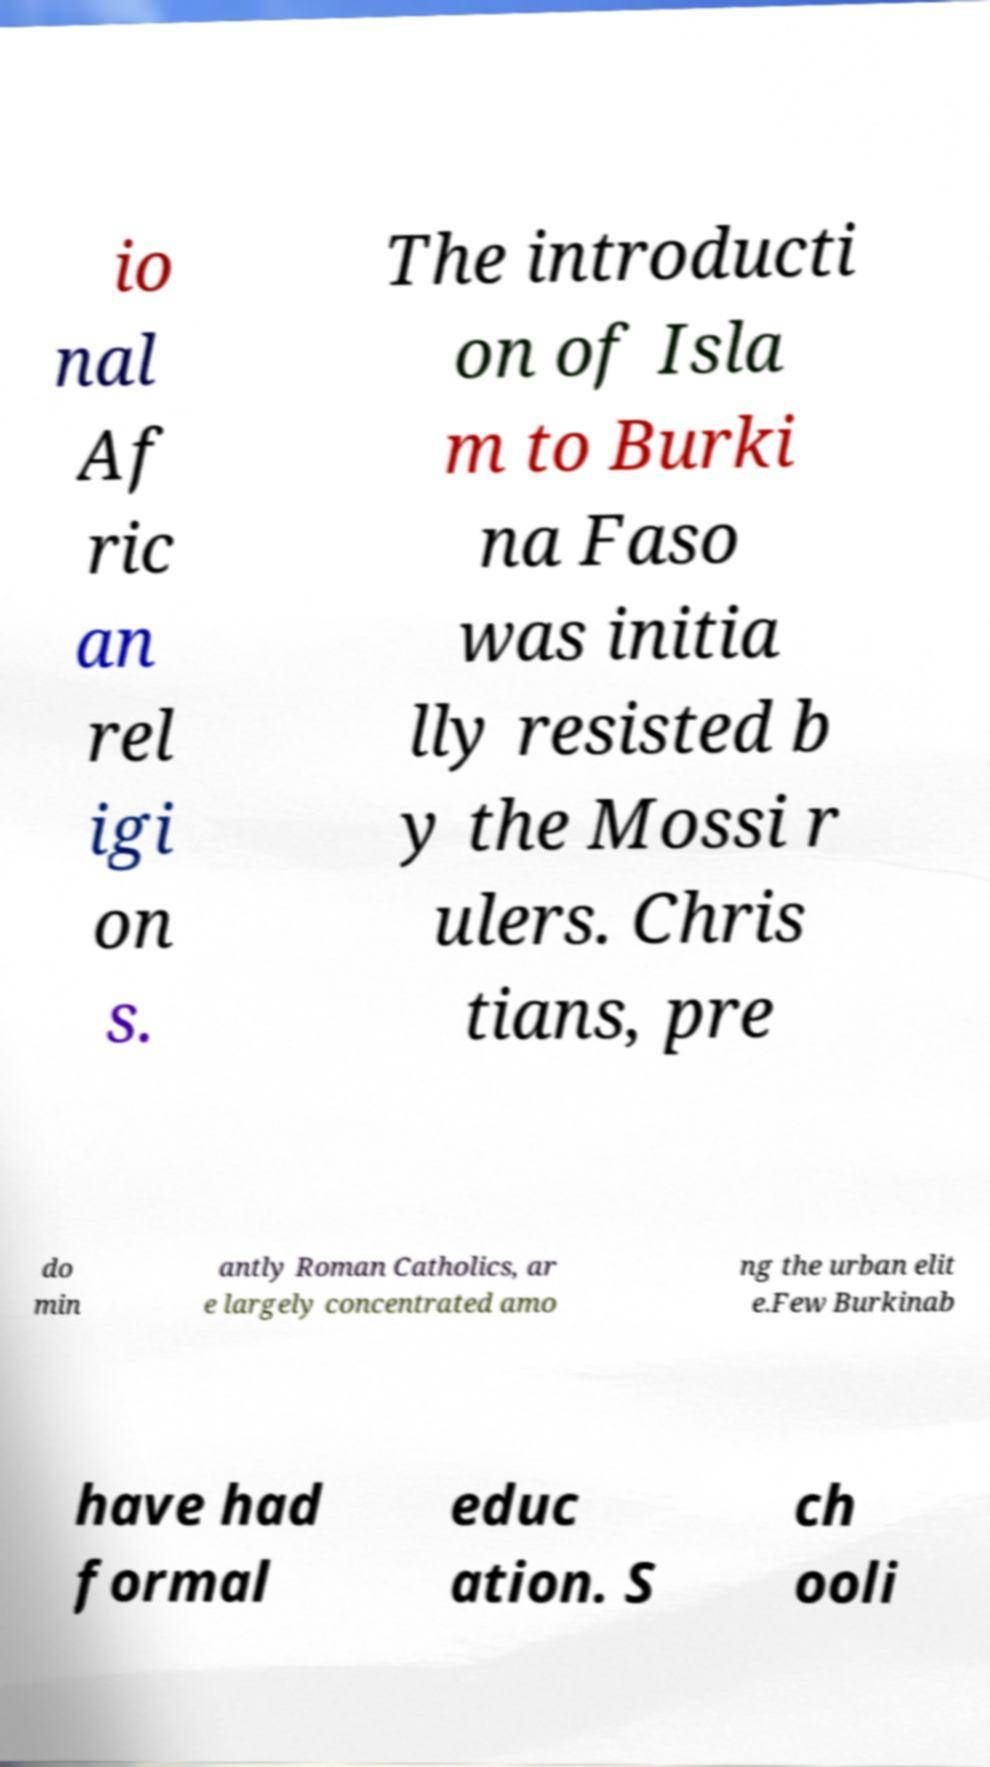Please read and relay the text visible in this image. What does it say? io nal Af ric an rel igi on s. The introducti on of Isla m to Burki na Faso was initia lly resisted b y the Mossi r ulers. Chris tians, pre do min antly Roman Catholics, ar e largely concentrated amo ng the urban elit e.Few Burkinab have had formal educ ation. S ch ooli 